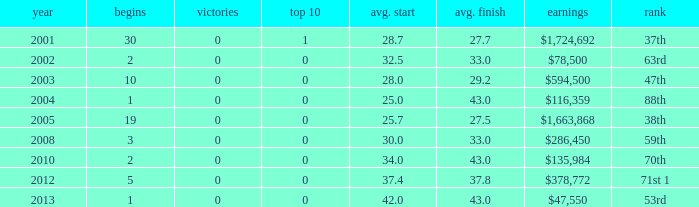How many starts for an average finish greater than 43? None. Could you help me parse every detail presented in this table? {'header': ['year', 'begins', 'victories', 'top 10', 'avg. start', 'avg. finish', 'earnings', 'rank'], 'rows': [['2001', '30', '0', '1', '28.7', '27.7', '$1,724,692', '37th'], ['2002', '2', '0', '0', '32.5', '33.0', '$78,500', '63rd'], ['2003', '10', '0', '0', '28.0', '29.2', '$594,500', '47th'], ['2004', '1', '0', '0', '25.0', '43.0', '$116,359', '88th'], ['2005', '19', '0', '0', '25.7', '27.5', '$1,663,868', '38th'], ['2008', '3', '0', '0', '30.0', '33.0', '$286,450', '59th'], ['2010', '2', '0', '0', '34.0', '43.0', '$135,984', '70th'], ['2012', '5', '0', '0', '37.4', '37.8', '$378,772', '71st 1'], ['2013', '1', '0', '0', '42.0', '43.0', '$47,550', '53rd']]} 